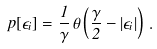Convert formula to latex. <formula><loc_0><loc_0><loc_500><loc_500>p [ \epsilon _ { i } ] = \frac { 1 } { \gamma } \, \theta \left ( \frac { \gamma } { 2 } - | \epsilon _ { i } | \right ) \, .</formula> 